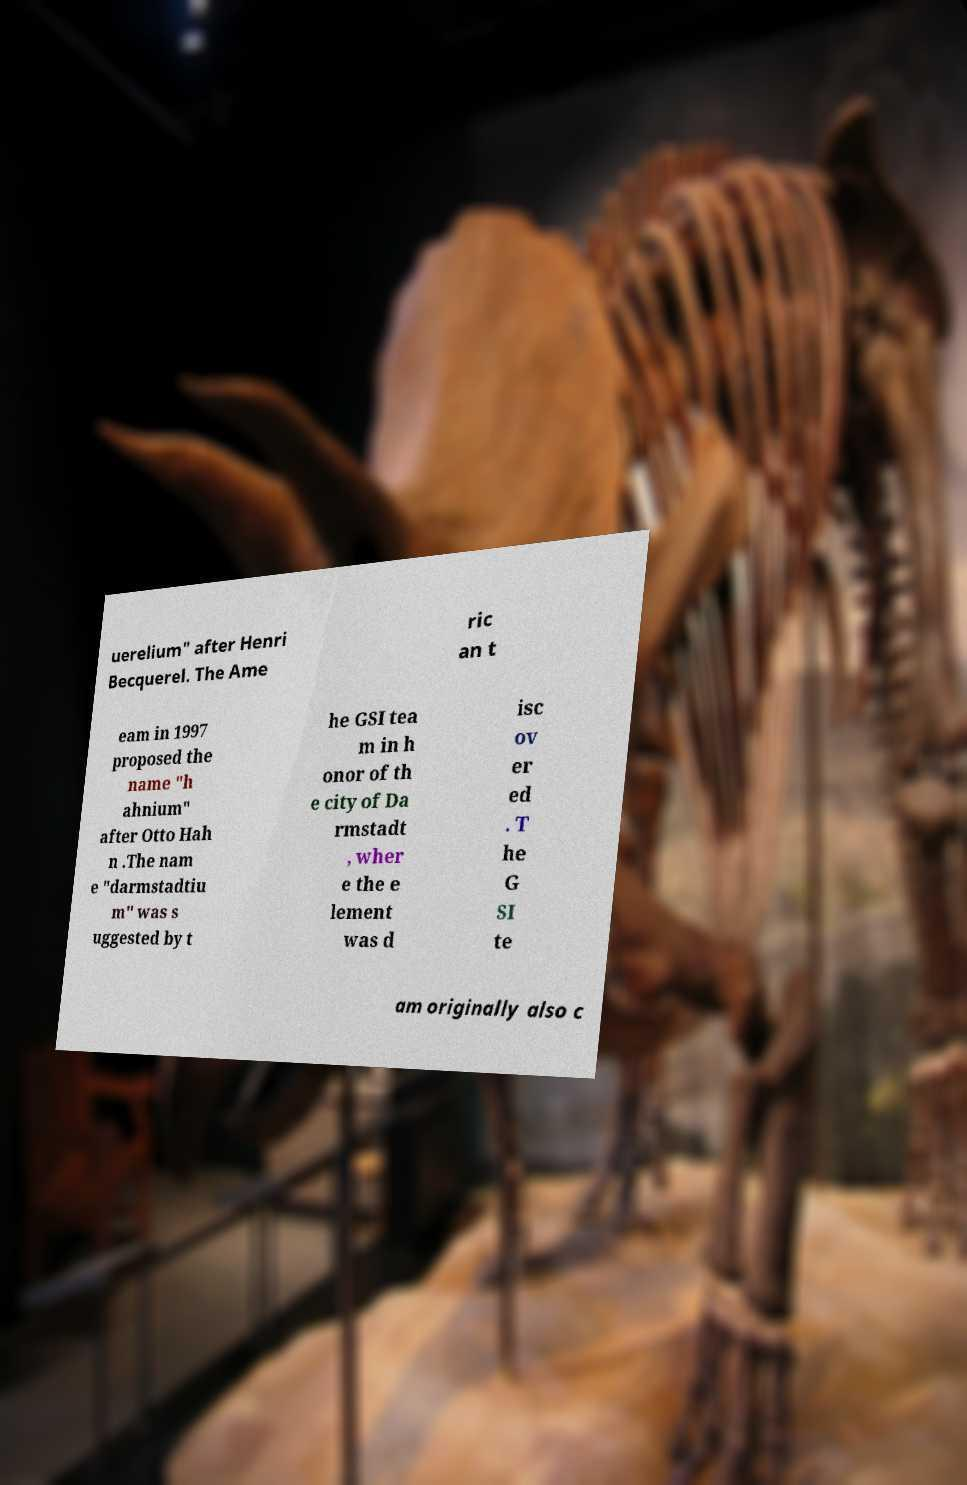I need the written content from this picture converted into text. Can you do that? uerelium" after Henri Becquerel. The Ame ric an t eam in 1997 proposed the name "h ahnium" after Otto Hah n .The nam e "darmstadtiu m" was s uggested by t he GSI tea m in h onor of th e city of Da rmstadt , wher e the e lement was d isc ov er ed . T he G SI te am originally also c 